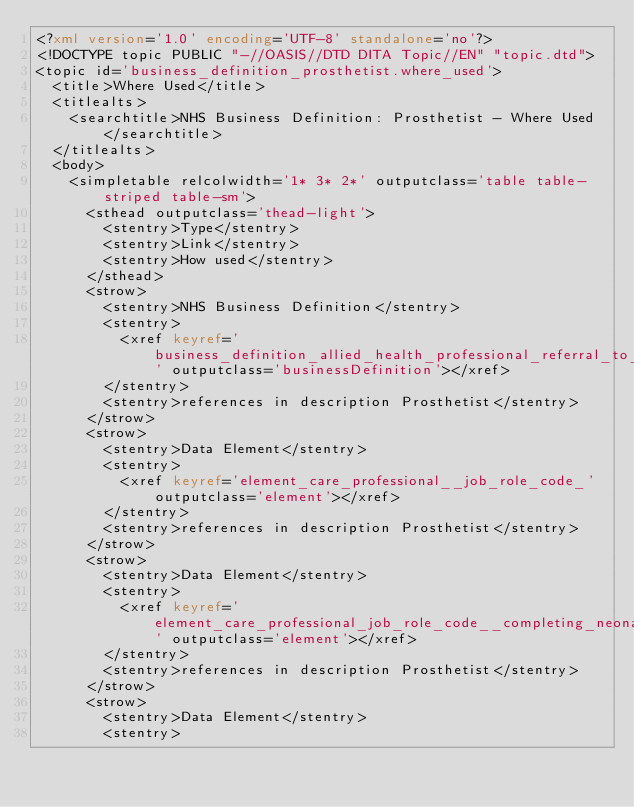<code> <loc_0><loc_0><loc_500><loc_500><_XML_><?xml version='1.0' encoding='UTF-8' standalone='no'?>
<!DOCTYPE topic PUBLIC "-//OASIS//DTD DITA Topic//EN" "topic.dtd">
<topic id='business_definition_prosthetist.where_used'>
  <title>Where Used</title>
  <titlealts>
    <searchtitle>NHS Business Definition: Prosthetist - Where Used</searchtitle>
  </titlealts>
  <body>
    <simpletable relcolwidth='1* 3* 2*' outputclass='table table-striped table-sm'>
      <sthead outputclass='thead-light'>
        <stentry>Type</stentry>
        <stentry>Link</stentry>
        <stentry>How used</stentry>
      </sthead>
      <strow>
        <stentry>NHS Business Definition</stentry>
        <stentry>
          <xref keyref='business_definition_allied_health_professional_referral_to_treatment_measurement' outputclass='businessDefinition'></xref>
        </stentry>
        <stentry>references in description Prosthetist</stentry>
      </strow>
      <strow>
        <stentry>Data Element</stentry>
        <stentry>
          <xref keyref='element_care_professional__job_role_code_' outputclass='element'></xref>
        </stentry>
        <stentry>references in description Prosthetist</stentry>
      </strow>
      <strow>
        <stentry>Data Element</stentry>
        <stentry>
          <xref keyref='element_care_professional_job_role_code__completing_neonatal_intensive_care_unit_admission_form_' outputclass='element'></xref>
        </stentry>
        <stentry>references in description Prosthetist</stentry>
      </strow>
      <strow>
        <stentry>Data Element</stentry>
        <stentry></code> 